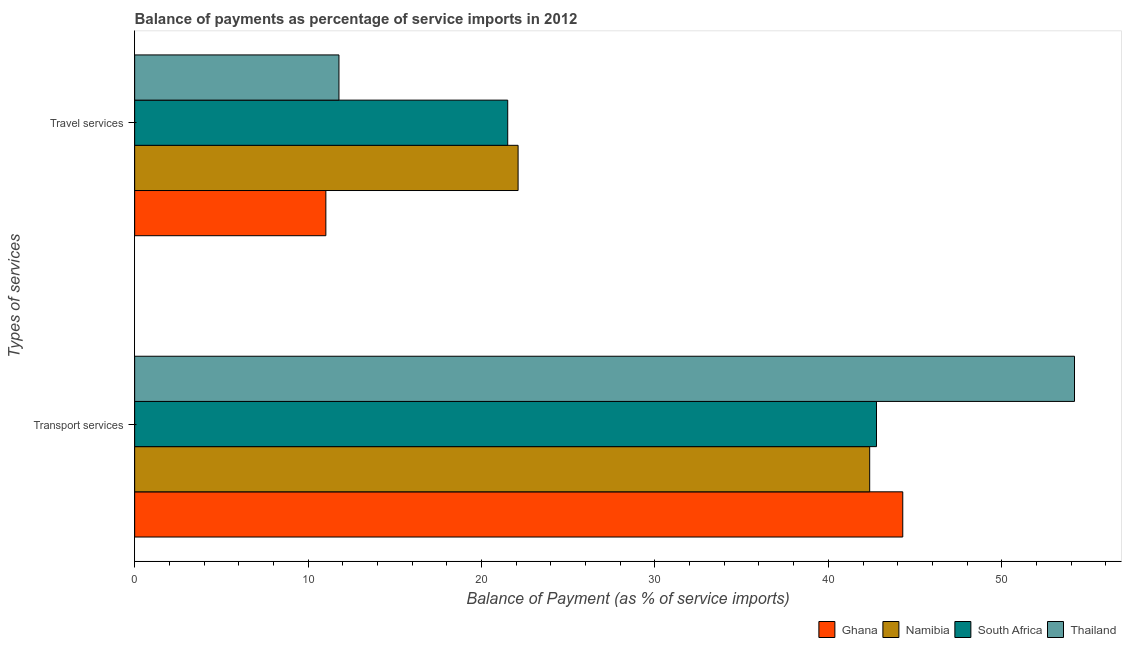Are the number of bars on each tick of the Y-axis equal?
Offer a very short reply. Yes. What is the label of the 2nd group of bars from the top?
Your answer should be compact. Transport services. What is the balance of payments of travel services in South Africa?
Make the answer very short. 21.51. Across all countries, what is the maximum balance of payments of transport services?
Offer a very short reply. 54.2. Across all countries, what is the minimum balance of payments of travel services?
Offer a terse response. 11.03. In which country was the balance of payments of transport services maximum?
Offer a very short reply. Thailand. In which country was the balance of payments of transport services minimum?
Your answer should be very brief. Namibia. What is the total balance of payments of travel services in the graph?
Your response must be concise. 66.43. What is the difference between the balance of payments of travel services in South Africa and that in Thailand?
Your answer should be compact. 9.73. What is the difference between the balance of payments of transport services in Thailand and the balance of payments of travel services in Ghana?
Your response must be concise. 43.17. What is the average balance of payments of transport services per country?
Your answer should be very brief. 45.91. What is the difference between the balance of payments of transport services and balance of payments of travel services in Ghana?
Offer a terse response. 33.27. In how many countries, is the balance of payments of transport services greater than 40 %?
Keep it short and to the point. 4. What is the ratio of the balance of payments of transport services in Ghana to that in Namibia?
Your answer should be very brief. 1.04. What does the 2nd bar from the top in Transport services represents?
Provide a succinct answer. South Africa. What does the 2nd bar from the bottom in Transport services represents?
Give a very brief answer. Namibia. Are the values on the major ticks of X-axis written in scientific E-notation?
Offer a very short reply. No. Where does the legend appear in the graph?
Provide a succinct answer. Bottom right. What is the title of the graph?
Ensure brevity in your answer.  Balance of payments as percentage of service imports in 2012. What is the label or title of the X-axis?
Ensure brevity in your answer.  Balance of Payment (as % of service imports). What is the label or title of the Y-axis?
Give a very brief answer. Types of services. What is the Balance of Payment (as % of service imports) of Ghana in Transport services?
Keep it short and to the point. 44.29. What is the Balance of Payment (as % of service imports) of Namibia in Transport services?
Give a very brief answer. 42.39. What is the Balance of Payment (as % of service imports) in South Africa in Transport services?
Offer a terse response. 42.78. What is the Balance of Payment (as % of service imports) of Thailand in Transport services?
Make the answer very short. 54.2. What is the Balance of Payment (as % of service imports) in Ghana in Travel services?
Give a very brief answer. 11.03. What is the Balance of Payment (as % of service imports) in Namibia in Travel services?
Make the answer very short. 22.11. What is the Balance of Payment (as % of service imports) in South Africa in Travel services?
Keep it short and to the point. 21.51. What is the Balance of Payment (as % of service imports) of Thailand in Travel services?
Provide a short and direct response. 11.78. Across all Types of services, what is the maximum Balance of Payment (as % of service imports) of Ghana?
Offer a terse response. 44.29. Across all Types of services, what is the maximum Balance of Payment (as % of service imports) in Namibia?
Your answer should be compact. 42.39. Across all Types of services, what is the maximum Balance of Payment (as % of service imports) in South Africa?
Give a very brief answer. 42.78. Across all Types of services, what is the maximum Balance of Payment (as % of service imports) of Thailand?
Ensure brevity in your answer.  54.2. Across all Types of services, what is the minimum Balance of Payment (as % of service imports) of Ghana?
Offer a terse response. 11.03. Across all Types of services, what is the minimum Balance of Payment (as % of service imports) of Namibia?
Your answer should be compact. 22.11. Across all Types of services, what is the minimum Balance of Payment (as % of service imports) in South Africa?
Provide a succinct answer. 21.51. Across all Types of services, what is the minimum Balance of Payment (as % of service imports) in Thailand?
Keep it short and to the point. 11.78. What is the total Balance of Payment (as % of service imports) in Ghana in the graph?
Your answer should be very brief. 55.32. What is the total Balance of Payment (as % of service imports) in Namibia in the graph?
Provide a succinct answer. 64.5. What is the total Balance of Payment (as % of service imports) in South Africa in the graph?
Provide a short and direct response. 64.29. What is the total Balance of Payment (as % of service imports) in Thailand in the graph?
Your response must be concise. 65.98. What is the difference between the Balance of Payment (as % of service imports) in Ghana in Transport services and that in Travel services?
Make the answer very short. 33.27. What is the difference between the Balance of Payment (as % of service imports) in Namibia in Transport services and that in Travel services?
Give a very brief answer. 20.27. What is the difference between the Balance of Payment (as % of service imports) in South Africa in Transport services and that in Travel services?
Keep it short and to the point. 21.27. What is the difference between the Balance of Payment (as % of service imports) of Thailand in Transport services and that in Travel services?
Ensure brevity in your answer.  42.42. What is the difference between the Balance of Payment (as % of service imports) of Ghana in Transport services and the Balance of Payment (as % of service imports) of Namibia in Travel services?
Your response must be concise. 22.18. What is the difference between the Balance of Payment (as % of service imports) of Ghana in Transport services and the Balance of Payment (as % of service imports) of South Africa in Travel services?
Provide a succinct answer. 22.78. What is the difference between the Balance of Payment (as % of service imports) of Ghana in Transport services and the Balance of Payment (as % of service imports) of Thailand in Travel services?
Ensure brevity in your answer.  32.51. What is the difference between the Balance of Payment (as % of service imports) of Namibia in Transport services and the Balance of Payment (as % of service imports) of South Africa in Travel services?
Make the answer very short. 20.87. What is the difference between the Balance of Payment (as % of service imports) in Namibia in Transport services and the Balance of Payment (as % of service imports) in Thailand in Travel services?
Offer a terse response. 30.6. What is the difference between the Balance of Payment (as % of service imports) in South Africa in Transport services and the Balance of Payment (as % of service imports) in Thailand in Travel services?
Your answer should be compact. 31. What is the average Balance of Payment (as % of service imports) in Ghana per Types of services?
Offer a very short reply. 27.66. What is the average Balance of Payment (as % of service imports) in Namibia per Types of services?
Offer a very short reply. 32.25. What is the average Balance of Payment (as % of service imports) of South Africa per Types of services?
Offer a very short reply. 32.15. What is the average Balance of Payment (as % of service imports) of Thailand per Types of services?
Offer a very short reply. 32.99. What is the difference between the Balance of Payment (as % of service imports) of Ghana and Balance of Payment (as % of service imports) of Namibia in Transport services?
Provide a succinct answer. 1.91. What is the difference between the Balance of Payment (as % of service imports) of Ghana and Balance of Payment (as % of service imports) of South Africa in Transport services?
Your response must be concise. 1.51. What is the difference between the Balance of Payment (as % of service imports) in Ghana and Balance of Payment (as % of service imports) in Thailand in Transport services?
Your answer should be compact. -9.9. What is the difference between the Balance of Payment (as % of service imports) of Namibia and Balance of Payment (as % of service imports) of South Africa in Transport services?
Ensure brevity in your answer.  -0.39. What is the difference between the Balance of Payment (as % of service imports) of Namibia and Balance of Payment (as % of service imports) of Thailand in Transport services?
Provide a succinct answer. -11.81. What is the difference between the Balance of Payment (as % of service imports) in South Africa and Balance of Payment (as % of service imports) in Thailand in Transport services?
Give a very brief answer. -11.42. What is the difference between the Balance of Payment (as % of service imports) in Ghana and Balance of Payment (as % of service imports) in Namibia in Travel services?
Your answer should be very brief. -11.09. What is the difference between the Balance of Payment (as % of service imports) of Ghana and Balance of Payment (as % of service imports) of South Africa in Travel services?
Provide a succinct answer. -10.49. What is the difference between the Balance of Payment (as % of service imports) in Ghana and Balance of Payment (as % of service imports) in Thailand in Travel services?
Your response must be concise. -0.75. What is the difference between the Balance of Payment (as % of service imports) in Namibia and Balance of Payment (as % of service imports) in South Africa in Travel services?
Ensure brevity in your answer.  0.6. What is the difference between the Balance of Payment (as % of service imports) of Namibia and Balance of Payment (as % of service imports) of Thailand in Travel services?
Your answer should be compact. 10.33. What is the difference between the Balance of Payment (as % of service imports) of South Africa and Balance of Payment (as % of service imports) of Thailand in Travel services?
Ensure brevity in your answer.  9.73. What is the ratio of the Balance of Payment (as % of service imports) in Ghana in Transport services to that in Travel services?
Offer a terse response. 4.02. What is the ratio of the Balance of Payment (as % of service imports) in Namibia in Transport services to that in Travel services?
Offer a terse response. 1.92. What is the ratio of the Balance of Payment (as % of service imports) in South Africa in Transport services to that in Travel services?
Provide a succinct answer. 1.99. What is the ratio of the Balance of Payment (as % of service imports) of Thailand in Transport services to that in Travel services?
Offer a very short reply. 4.6. What is the difference between the highest and the second highest Balance of Payment (as % of service imports) of Ghana?
Keep it short and to the point. 33.27. What is the difference between the highest and the second highest Balance of Payment (as % of service imports) in Namibia?
Your response must be concise. 20.27. What is the difference between the highest and the second highest Balance of Payment (as % of service imports) of South Africa?
Provide a succinct answer. 21.27. What is the difference between the highest and the second highest Balance of Payment (as % of service imports) of Thailand?
Provide a succinct answer. 42.42. What is the difference between the highest and the lowest Balance of Payment (as % of service imports) of Ghana?
Ensure brevity in your answer.  33.27. What is the difference between the highest and the lowest Balance of Payment (as % of service imports) in Namibia?
Provide a short and direct response. 20.27. What is the difference between the highest and the lowest Balance of Payment (as % of service imports) in South Africa?
Ensure brevity in your answer.  21.27. What is the difference between the highest and the lowest Balance of Payment (as % of service imports) in Thailand?
Offer a very short reply. 42.42. 